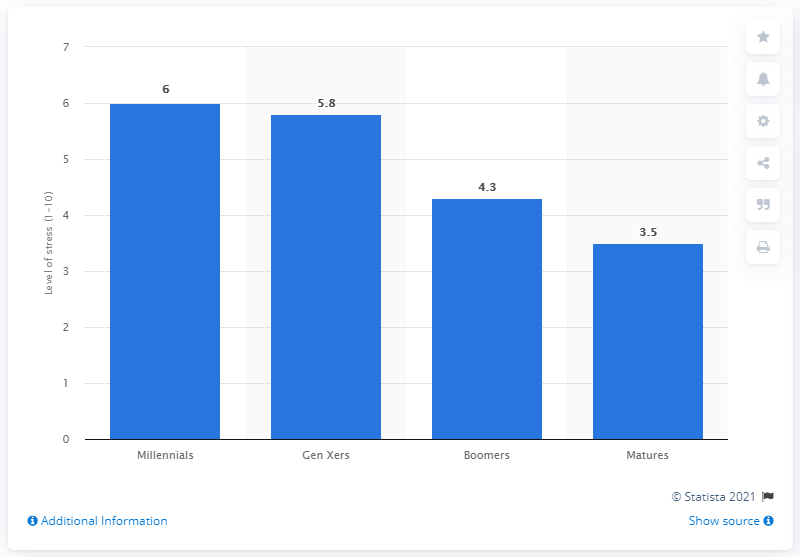List a handful of essential elements in this visual. In 2015, the average stress level among Gen Xers was 5.8. 